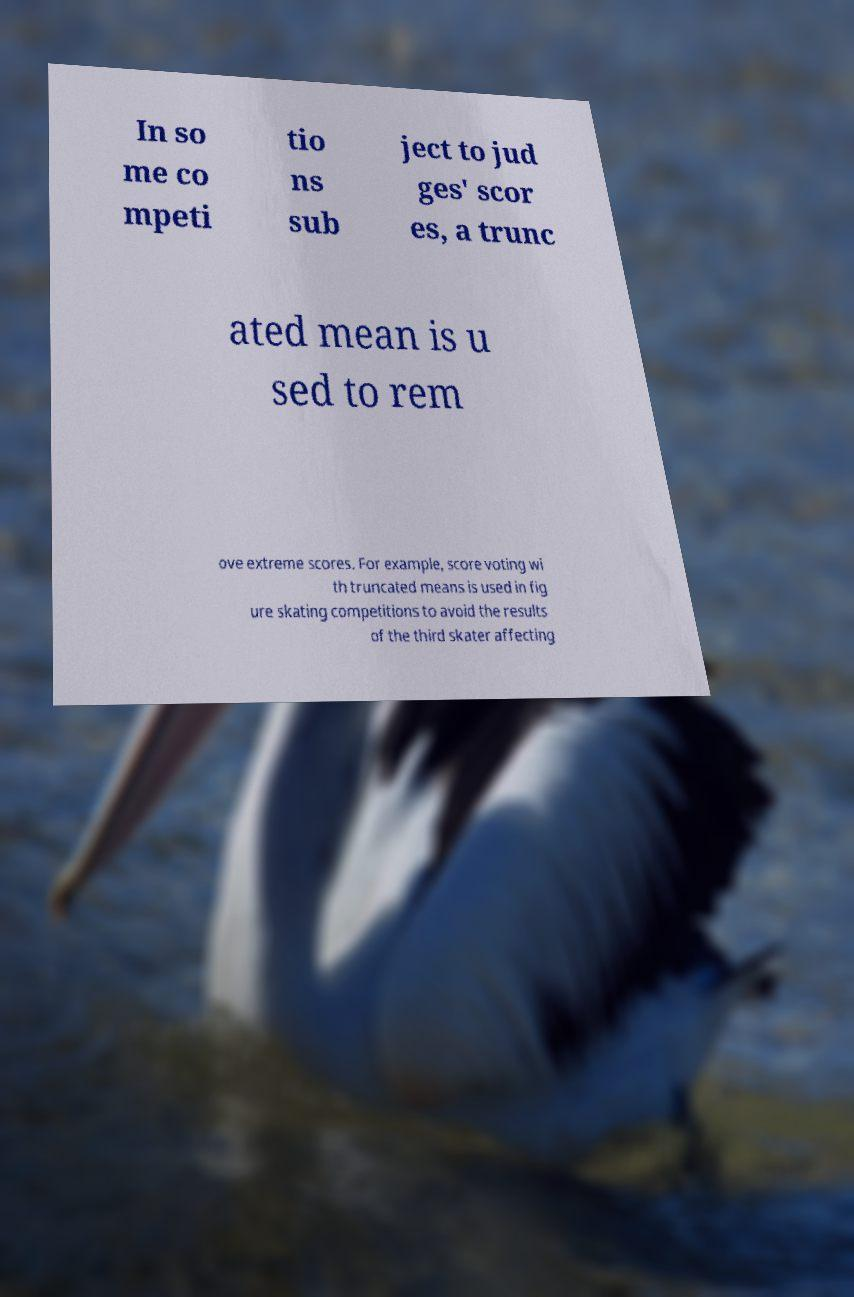Could you extract and type out the text from this image? In so me co mpeti tio ns sub ject to jud ges' scor es, a trunc ated mean is u sed to rem ove extreme scores. For example, score voting wi th truncated means is used in fig ure skating competitions to avoid the results of the third skater affecting 